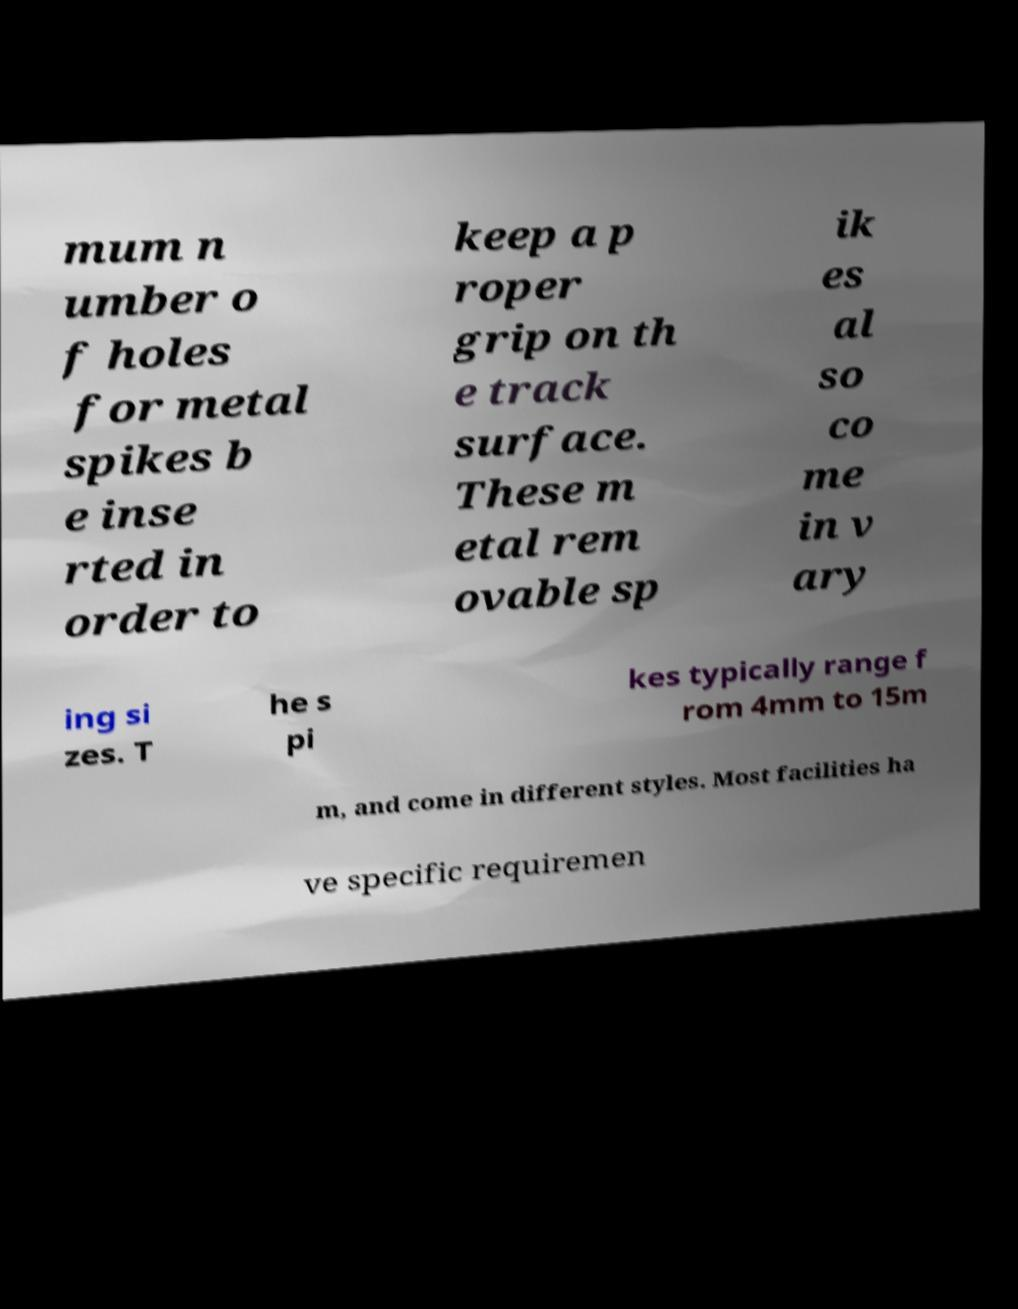Could you extract and type out the text from this image? mum n umber o f holes for metal spikes b e inse rted in order to keep a p roper grip on th e track surface. These m etal rem ovable sp ik es al so co me in v ary ing si zes. T he s pi kes typically range f rom 4mm to 15m m, and come in different styles. Most facilities ha ve specific requiremen 